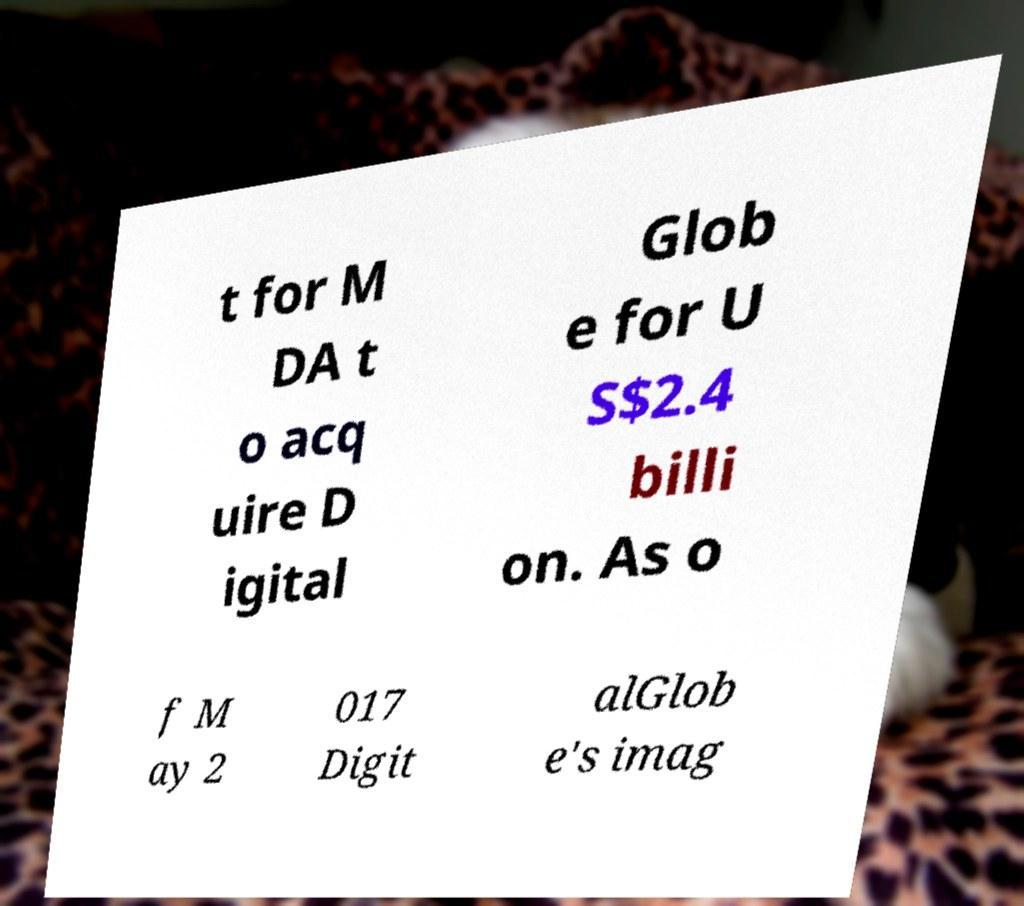Can you read and provide the text displayed in the image?This photo seems to have some interesting text. Can you extract and type it out for me? t for M DA t o acq uire D igital Glob e for U S$2.4 billi on. As o f M ay 2 017 Digit alGlob e's imag 